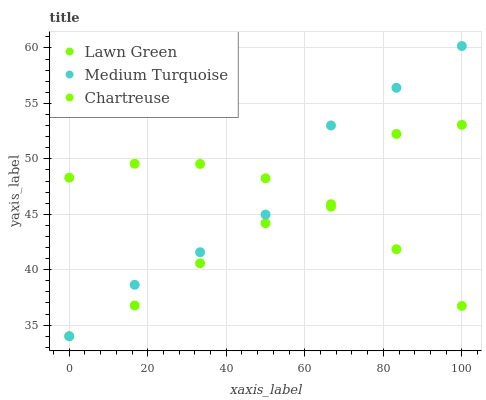Does Lawn Green have the minimum area under the curve?
Answer yes or no. Yes. Does Medium Turquoise have the maximum area under the curve?
Answer yes or no. Yes. Does Chartreuse have the minimum area under the curve?
Answer yes or no. No. Does Chartreuse have the maximum area under the curve?
Answer yes or no. No. Is Chartreuse the smoothest?
Answer yes or no. Yes. Is Lawn Green the roughest?
Answer yes or no. Yes. Is Medium Turquoise the smoothest?
Answer yes or no. No. Is Medium Turquoise the roughest?
Answer yes or no. No. Does Lawn Green have the lowest value?
Answer yes or no. Yes. Does Chartreuse have the lowest value?
Answer yes or no. No. Does Medium Turquoise have the highest value?
Answer yes or no. Yes. Does Chartreuse have the highest value?
Answer yes or no. No. Does Medium Turquoise intersect Lawn Green?
Answer yes or no. Yes. Is Medium Turquoise less than Lawn Green?
Answer yes or no. No. Is Medium Turquoise greater than Lawn Green?
Answer yes or no. No. 